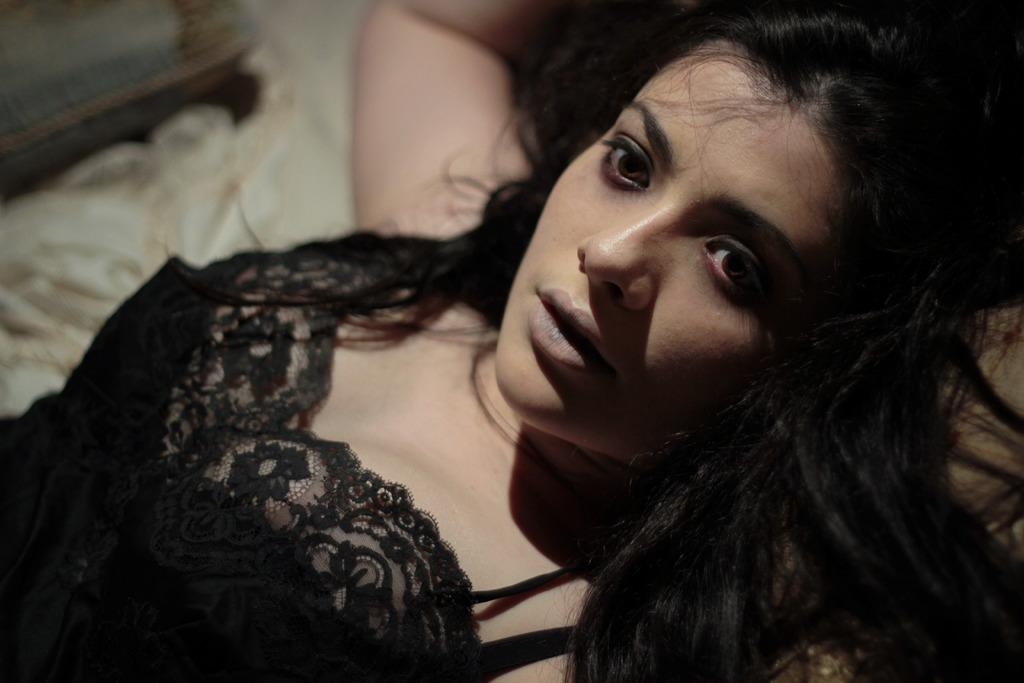Who is present in the image? There is a woman in the image. What is the woman wearing? The woman is wearing a black dress. What type of letter is the woman holding in the image? There is no letter present in the image; the woman is simply wearing a black dress. 